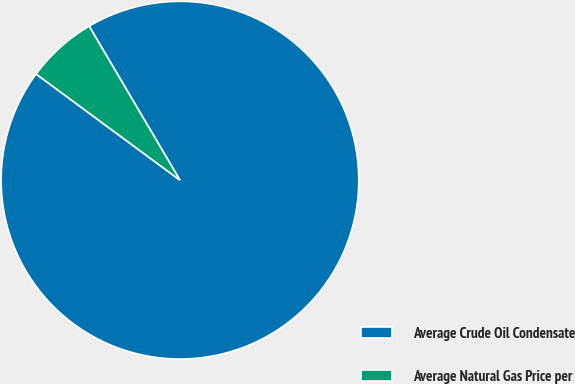Convert chart to OTSL. <chart><loc_0><loc_0><loc_500><loc_500><pie_chart><fcel>Average Crude Oil Condensate<fcel>Average Natural Gas Price per<nl><fcel>93.6%<fcel>6.4%<nl></chart> 